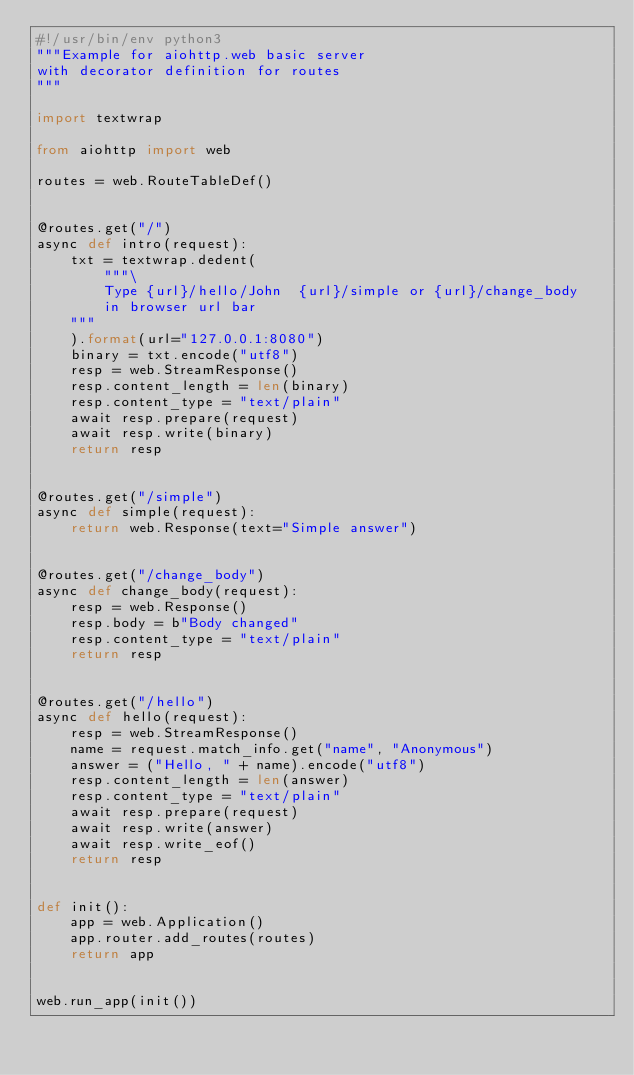<code> <loc_0><loc_0><loc_500><loc_500><_Python_>#!/usr/bin/env python3
"""Example for aiohttp.web basic server
with decorator definition for routes
"""

import textwrap

from aiohttp import web

routes = web.RouteTableDef()


@routes.get("/")
async def intro(request):
    txt = textwrap.dedent(
        """\
        Type {url}/hello/John  {url}/simple or {url}/change_body
        in browser url bar
    """
    ).format(url="127.0.0.1:8080")
    binary = txt.encode("utf8")
    resp = web.StreamResponse()
    resp.content_length = len(binary)
    resp.content_type = "text/plain"
    await resp.prepare(request)
    await resp.write(binary)
    return resp


@routes.get("/simple")
async def simple(request):
    return web.Response(text="Simple answer")


@routes.get("/change_body")
async def change_body(request):
    resp = web.Response()
    resp.body = b"Body changed"
    resp.content_type = "text/plain"
    return resp


@routes.get("/hello")
async def hello(request):
    resp = web.StreamResponse()
    name = request.match_info.get("name", "Anonymous")
    answer = ("Hello, " + name).encode("utf8")
    resp.content_length = len(answer)
    resp.content_type = "text/plain"
    await resp.prepare(request)
    await resp.write(answer)
    await resp.write_eof()
    return resp


def init():
    app = web.Application()
    app.router.add_routes(routes)
    return app


web.run_app(init())
</code> 